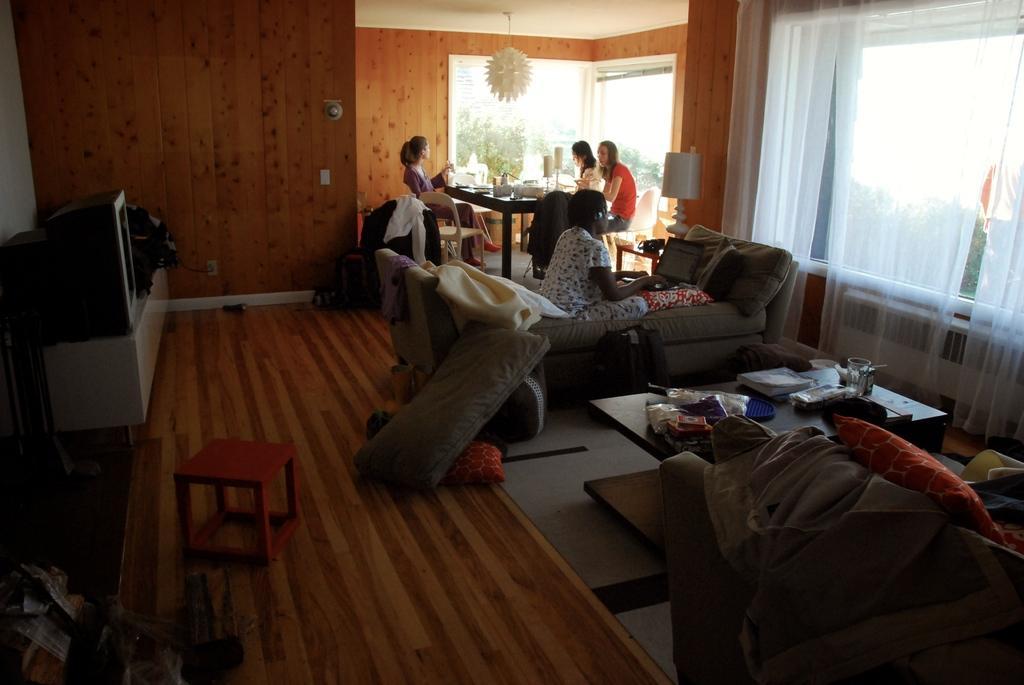Describe this image in one or two sentences. In this image there is a person sitting on the couch is using the laptop, on the couch there are cushions and some other objects, beside the women there are a few other women sitting on the chairs, in front of them on the dining table there are some objects, in this room there is television and some other objects on a platform and there is a stool, cushions and other objects on the floor and there are some objects on the table and there is a couch with cushions and some objects on it and there are lamps and switch boards on the walls and there is a lamp hanging from the ceiling, in the background of the image there are walls, beside the wall there is a glass wall with curtains and there is a room heater, through the window we can see there are trees on the outside. 